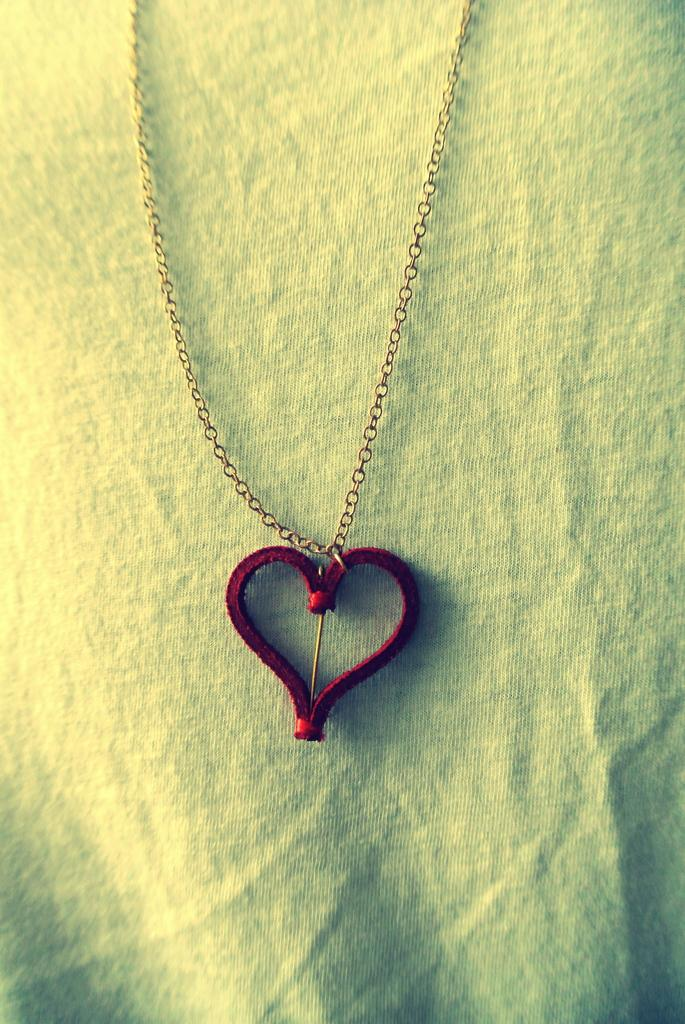What is present in the image that resembles a jewelry item? There is a locket in the image. What is connected to the locket in the image? There is a chain in the image that is connected to the locket. What can be seen in the background of the image? There is a cloth in the background of the image. What direction is the tail of the spotted animal pointing in the image? There is no spotted animal or tail present in the image. 